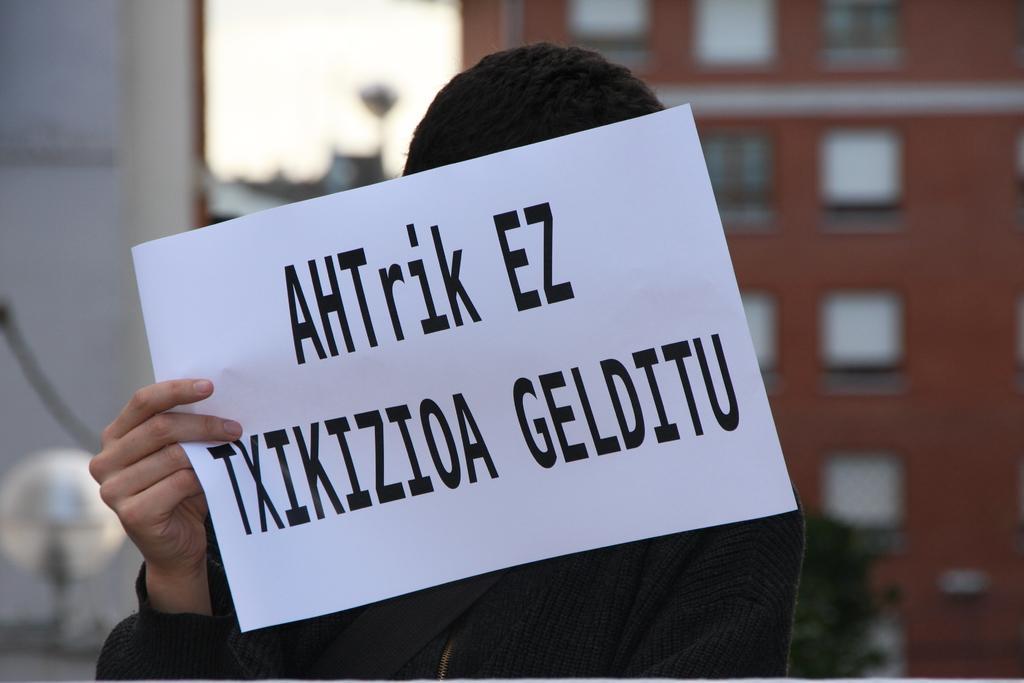Could you give a brief overview of what you see in this image? In this picture there is a woman who is wearing sweater and the holding a paper. In the background I can see the buildings. At the top I can see the sky. 